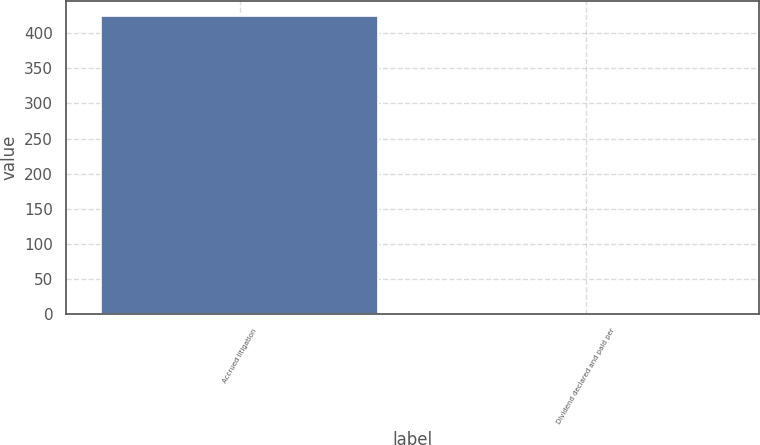Convert chart. <chart><loc_0><loc_0><loc_500><loc_500><bar_chart><fcel>Accrued litigation<fcel>Dividend declared and paid per<nl><fcel>425<fcel>0.15<nl></chart> 